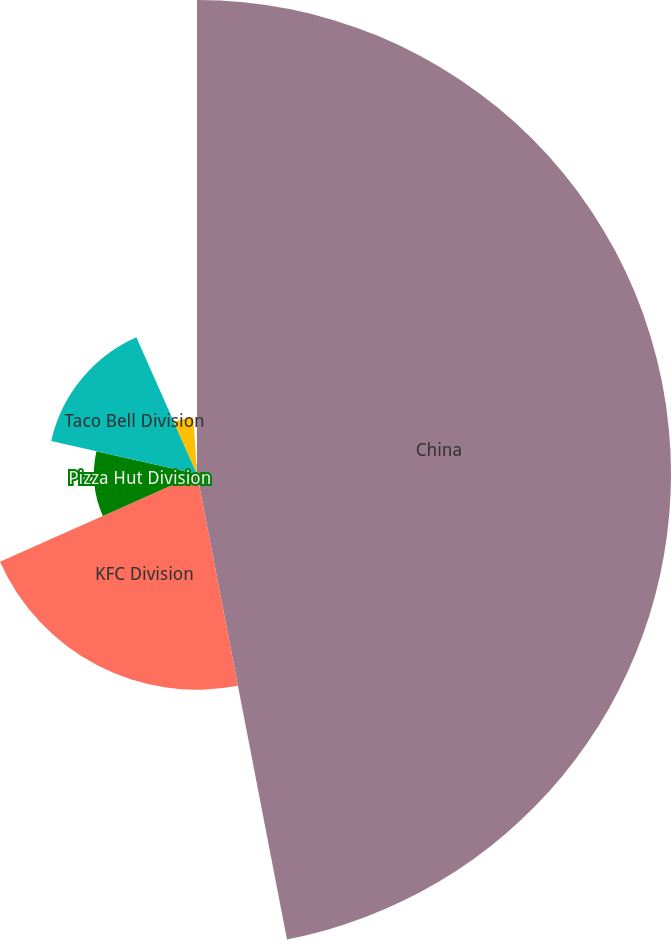Convert chart. <chart><loc_0><loc_0><loc_500><loc_500><pie_chart><fcel>China<fcel>KFC Division<fcel>Pizza Hut Division<fcel>Taco Bell Division<fcel>India<fcel>Corporate<nl><fcel>46.96%<fcel>21.37%<fcel>10.21%<fcel>14.81%<fcel>5.62%<fcel>1.03%<nl></chart> 